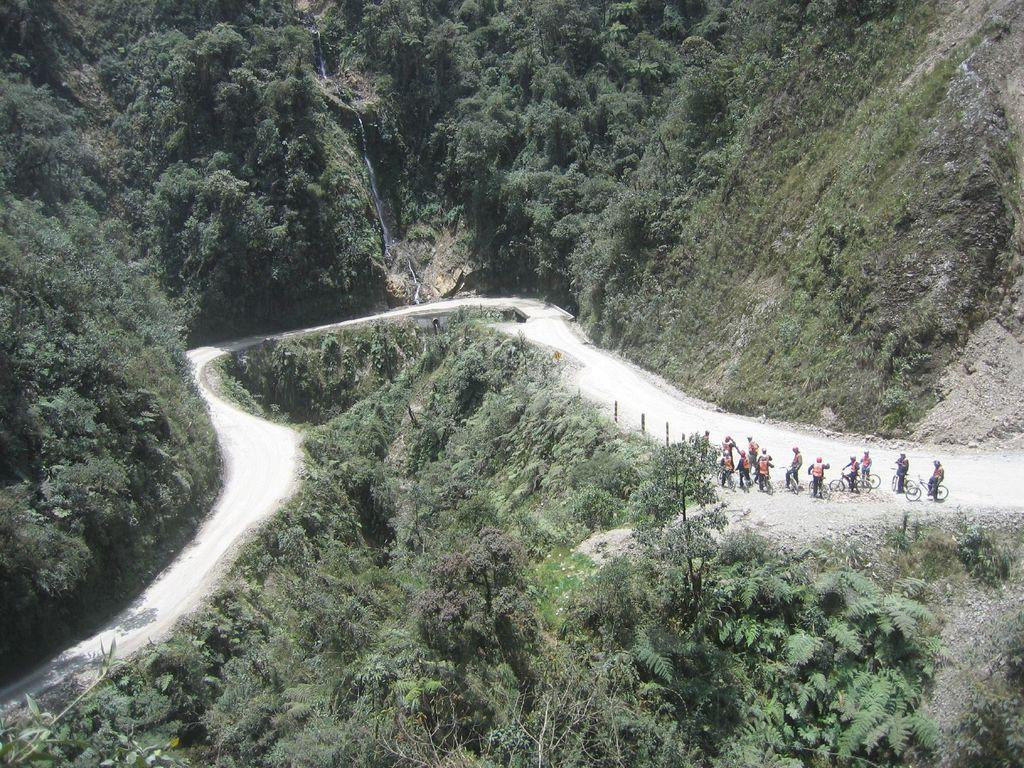Who or what can be seen in the image? There are persons in the image. What are the persons wearing on their heads? The persons are wearing helmets. What activity are the persons engaged in? The persons are riding bicycles. What type of surface can be seen in the image? There is a road visible in the image. What natural feature can be seen in the background of the image? There are trees on a mountain in the image. How does the feeling of excitement manifest in the image? The image does not convey feelings or emotions; it only shows the persons riding bicycles and wearing helmets. Can you describe the bite of the apple that the person is holding in the image? There is no apple or any other food item present in the image. 